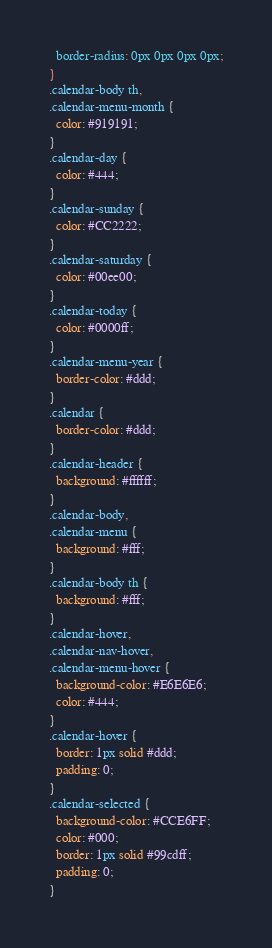<code> <loc_0><loc_0><loc_500><loc_500><_CSS_>  border-radius: 0px 0px 0px 0px;
}
.calendar-body th,
.calendar-menu-month {
  color: #919191;
}
.calendar-day {
  color: #444;
}
.calendar-sunday {
  color: #CC2222;
}
.calendar-saturday {
  color: #00ee00;
}
.calendar-today {
  color: #0000ff;
}
.calendar-menu-year {
  border-color: #ddd;
}
.calendar {
  border-color: #ddd;
}
.calendar-header {
  background: #ffffff;
}
.calendar-body,
.calendar-menu {
  background: #fff;
}
.calendar-body th {
  background: #fff;
}
.calendar-hover,
.calendar-nav-hover,
.calendar-menu-hover {
  background-color: #E6E6E6;
  color: #444;
}
.calendar-hover {
  border: 1px solid #ddd;
  padding: 0;
}
.calendar-selected {
  background-color: #CCE6FF;
  color: #000;
  border: 1px solid #99cdff;
  padding: 0;
}
</code> 